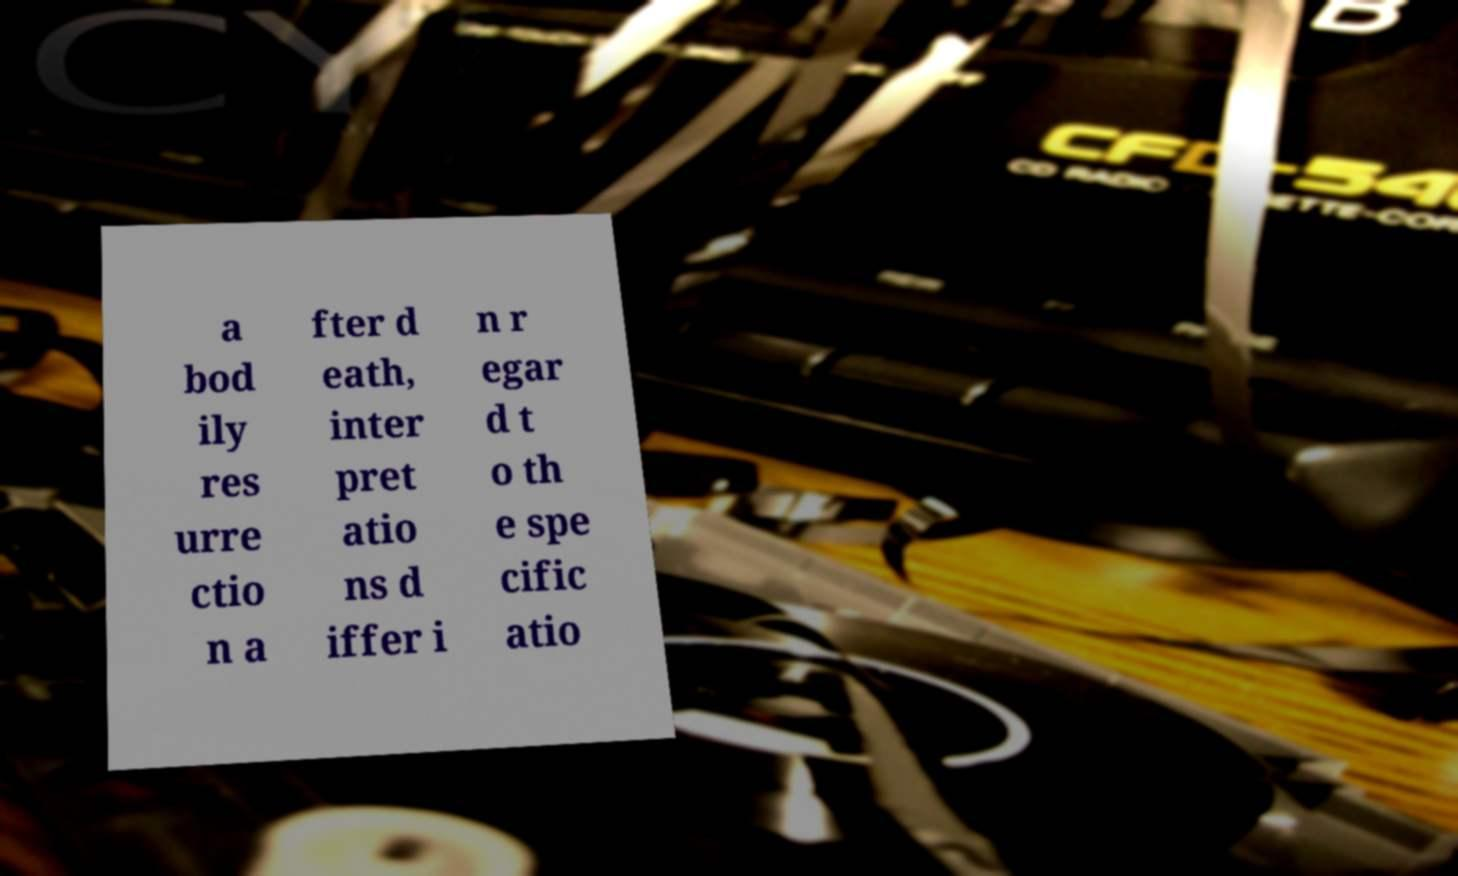What messages or text are displayed in this image? I need them in a readable, typed format. a bod ily res urre ctio n a fter d eath, inter pret atio ns d iffer i n r egar d t o th e spe cific atio 